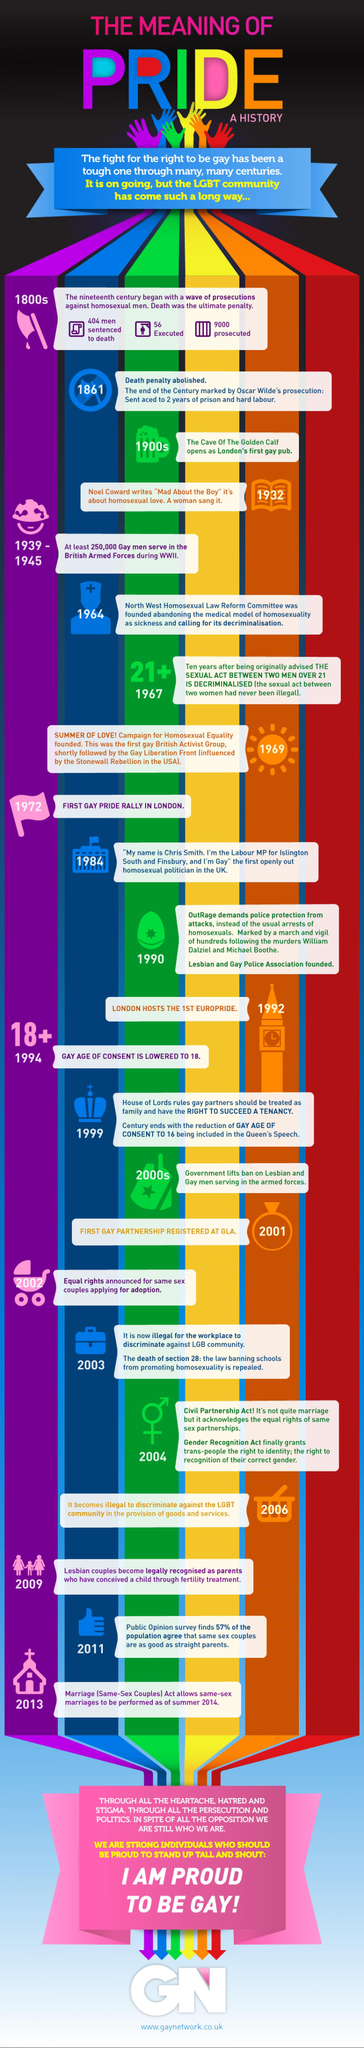Outline some significant characteristics in this image. The committee that called for the decriminalization of homosexuality was founded in 1964. The Campaign for Homosexual Equality was founded in 1969. It is not known how many homosexual men were sentenced to death in the 1800s. The search returned a 404 error. In the 1800s, approximately 9000 homosexual men were prosecuted. In 1999, the House of Lords approved tenancy rights for gay partners. 